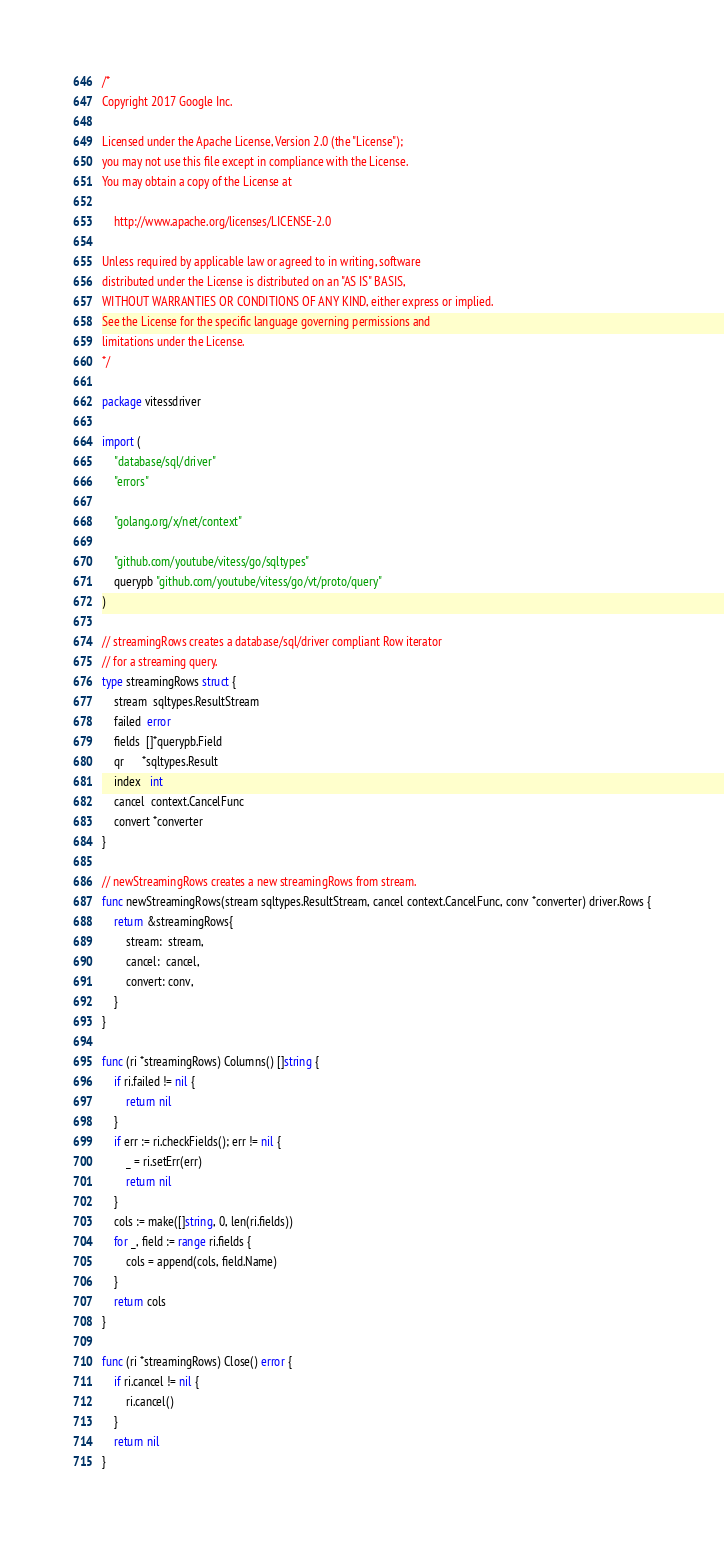Convert code to text. <code><loc_0><loc_0><loc_500><loc_500><_Go_>/*
Copyright 2017 Google Inc.

Licensed under the Apache License, Version 2.0 (the "License");
you may not use this file except in compliance with the License.
You may obtain a copy of the License at

    http://www.apache.org/licenses/LICENSE-2.0

Unless required by applicable law or agreed to in writing, software
distributed under the License is distributed on an "AS IS" BASIS,
WITHOUT WARRANTIES OR CONDITIONS OF ANY KIND, either express or implied.
See the License for the specific language governing permissions and
limitations under the License.
*/

package vitessdriver

import (
	"database/sql/driver"
	"errors"

	"golang.org/x/net/context"

	"github.com/youtube/vitess/go/sqltypes"
	querypb "github.com/youtube/vitess/go/vt/proto/query"
)

// streamingRows creates a database/sql/driver compliant Row iterator
// for a streaming query.
type streamingRows struct {
	stream  sqltypes.ResultStream
	failed  error
	fields  []*querypb.Field
	qr      *sqltypes.Result
	index   int
	cancel  context.CancelFunc
	convert *converter
}

// newStreamingRows creates a new streamingRows from stream.
func newStreamingRows(stream sqltypes.ResultStream, cancel context.CancelFunc, conv *converter) driver.Rows {
	return &streamingRows{
		stream:  stream,
		cancel:  cancel,
		convert: conv,
	}
}

func (ri *streamingRows) Columns() []string {
	if ri.failed != nil {
		return nil
	}
	if err := ri.checkFields(); err != nil {
		_ = ri.setErr(err)
		return nil
	}
	cols := make([]string, 0, len(ri.fields))
	for _, field := range ri.fields {
		cols = append(cols, field.Name)
	}
	return cols
}

func (ri *streamingRows) Close() error {
	if ri.cancel != nil {
		ri.cancel()
	}
	return nil
}
</code> 